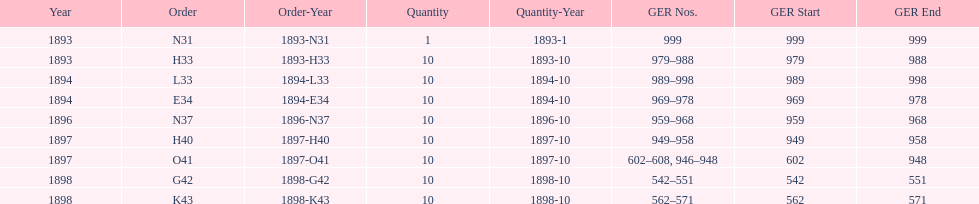What order is listed first at the top of the table? N31. 